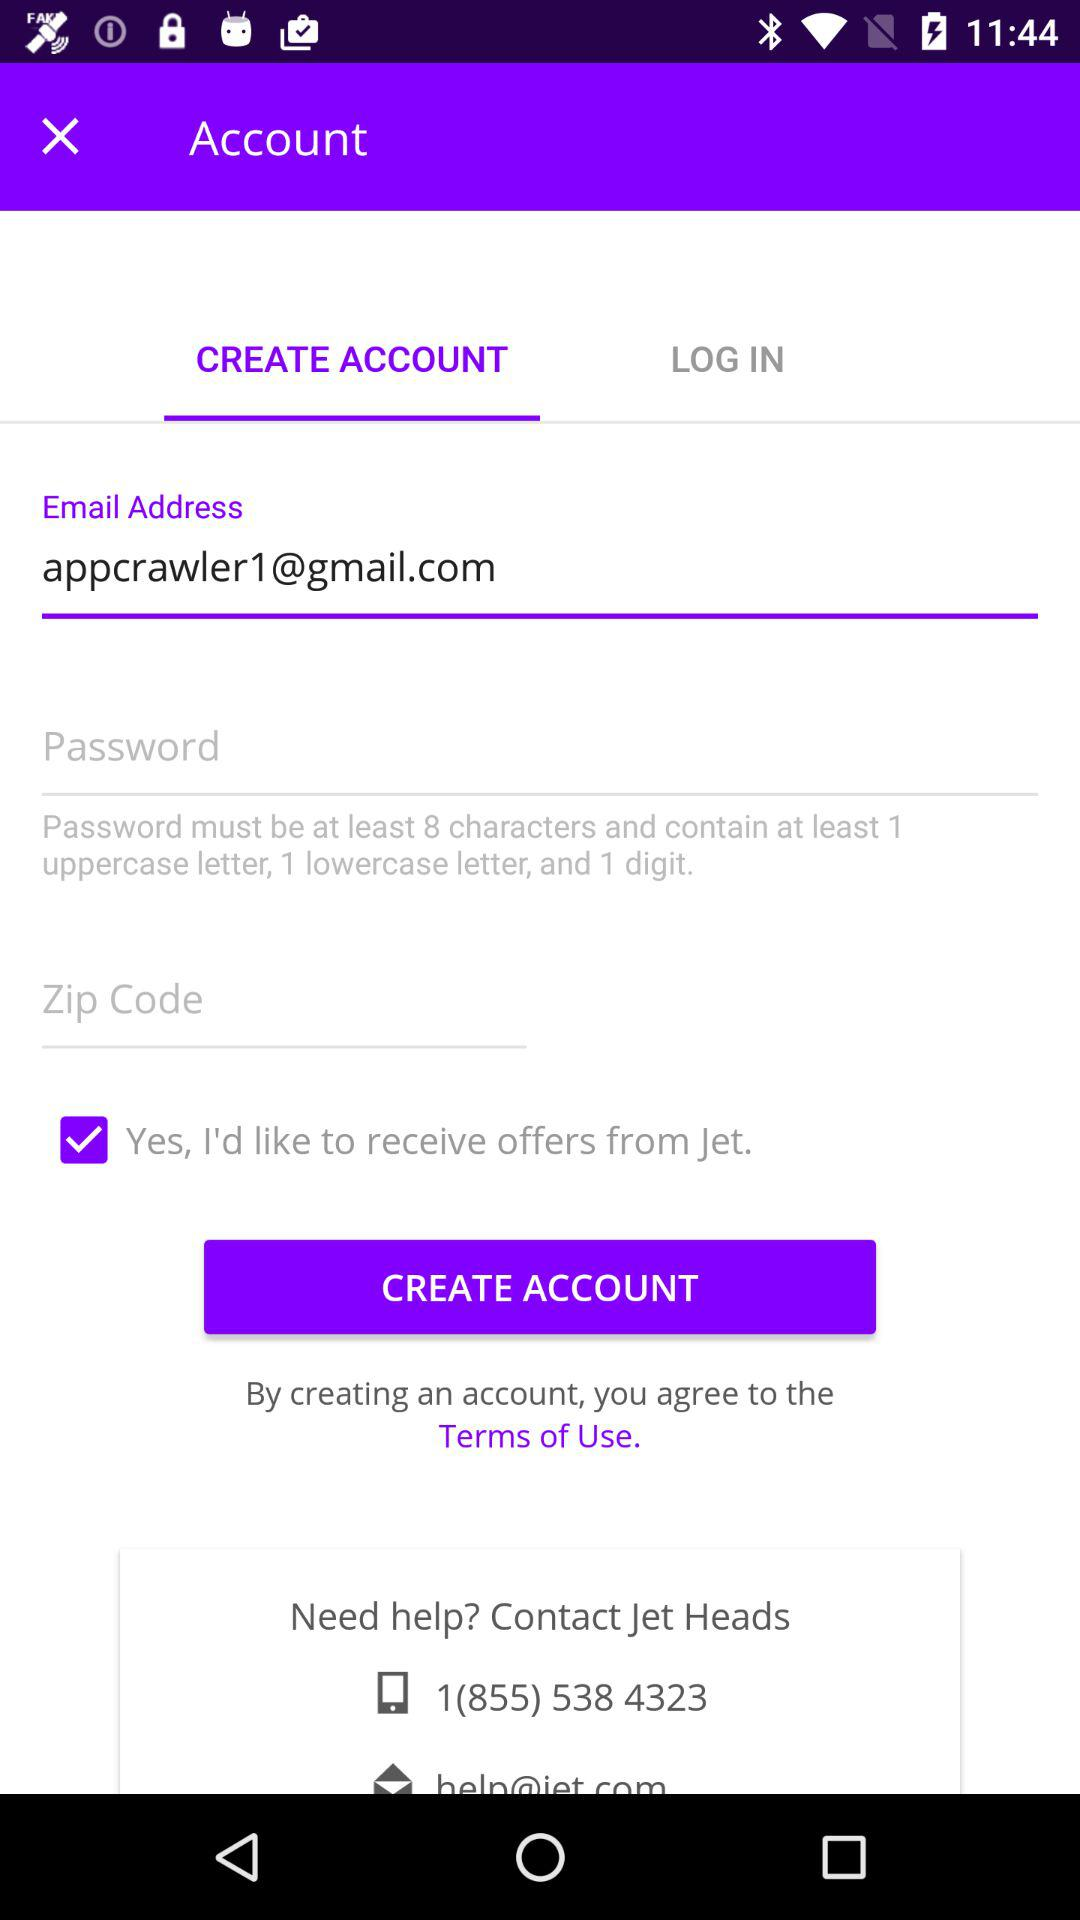What is the email address? The email address is appcrawler1@gmail.com. 